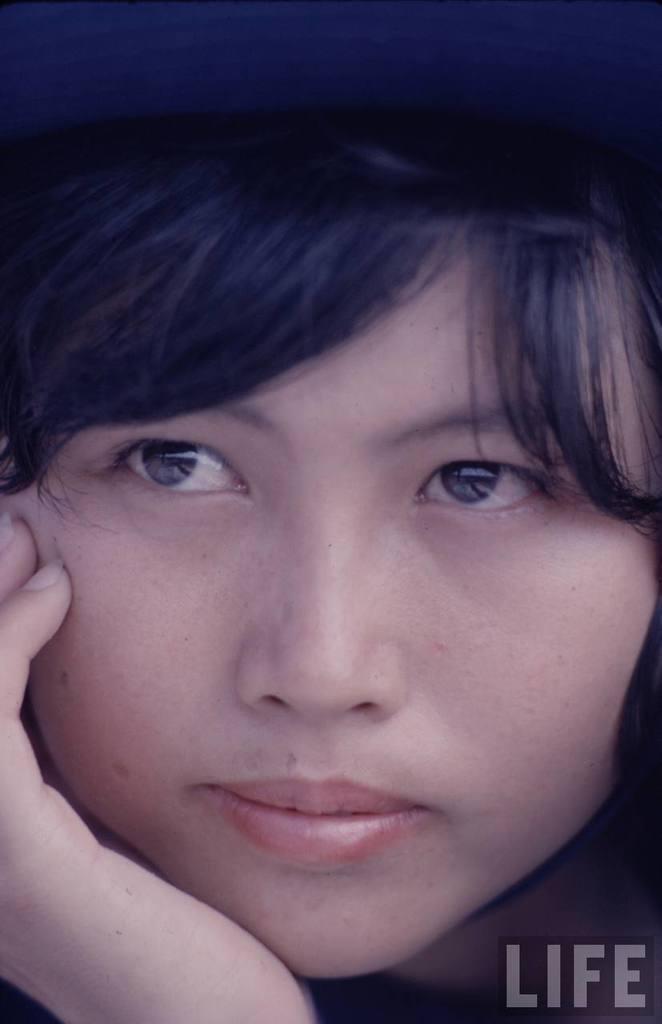Describe this image in one or two sentences. In this picture we can see a person's face and hand, there is some text at the right bottom. 